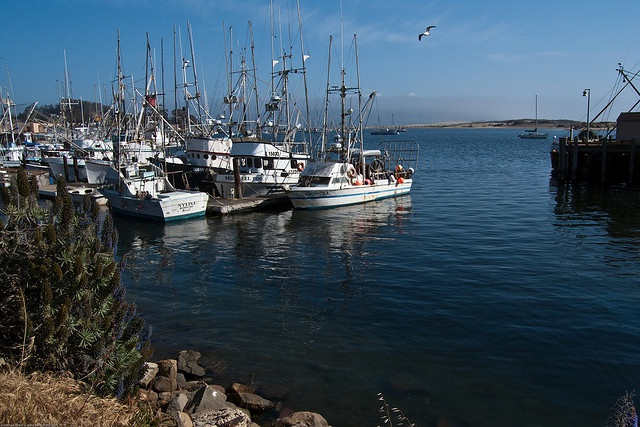Describe the objects in this image and their specific colors. I can see boat in teal, gray, and black tones, boat in teal, black, and gray tones, boat in teal, black, lightgray, gray, and darkgray tones, boat in teal, lightgray, black, gray, and darkgray tones, and boat in teal, gray, black, darkgray, and lightgray tones in this image. 